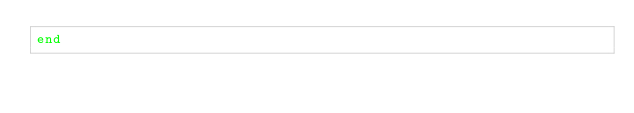Convert code to text. <code><loc_0><loc_0><loc_500><loc_500><_Ruby_>end
</code> 